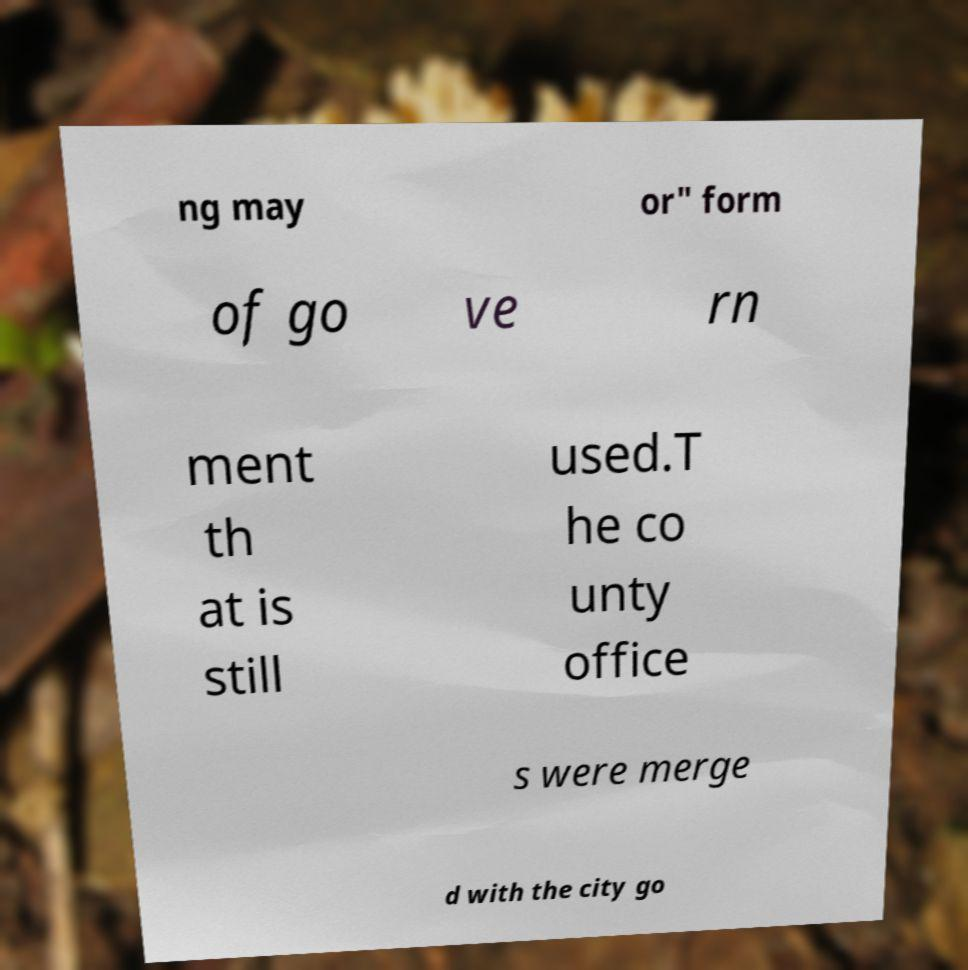Please read and relay the text visible in this image. What does it say? ng may or" form of go ve rn ment th at is still used.T he co unty office s were merge d with the city go 